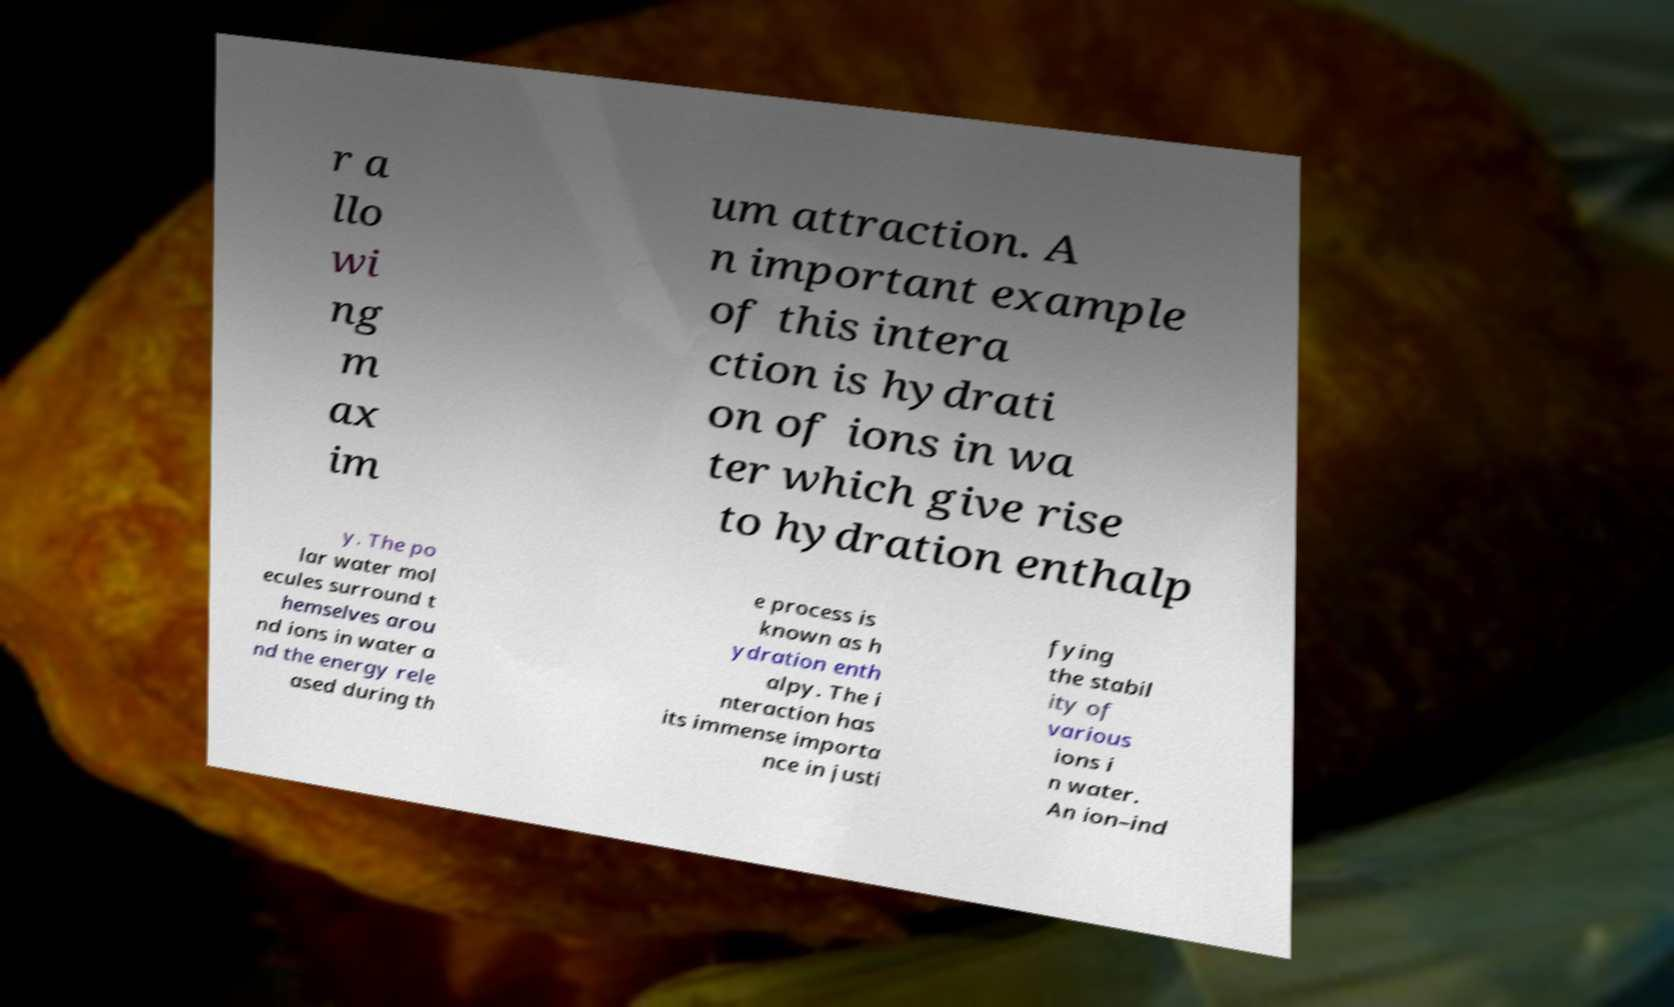Can you read and provide the text displayed in the image?This photo seems to have some interesting text. Can you extract and type it out for me? r a llo wi ng m ax im um attraction. A n important example of this intera ction is hydrati on of ions in wa ter which give rise to hydration enthalp y. The po lar water mol ecules surround t hemselves arou nd ions in water a nd the energy rele ased during th e process is known as h ydration enth alpy. The i nteraction has its immense importa nce in justi fying the stabil ity of various ions i n water. An ion–ind 